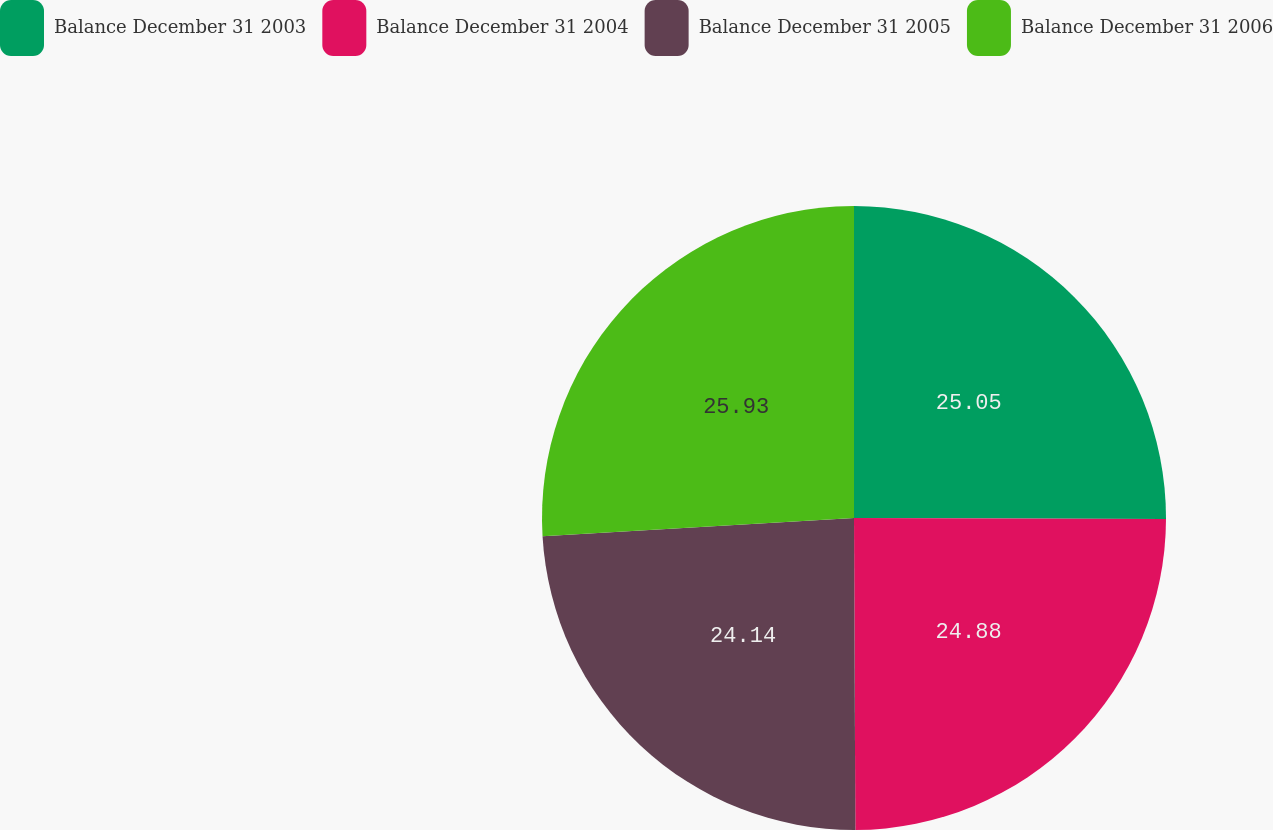Convert chart. <chart><loc_0><loc_0><loc_500><loc_500><pie_chart><fcel>Balance December 31 2003<fcel>Balance December 31 2004<fcel>Balance December 31 2005<fcel>Balance December 31 2006<nl><fcel>25.05%<fcel>24.88%<fcel>24.14%<fcel>25.93%<nl></chart> 